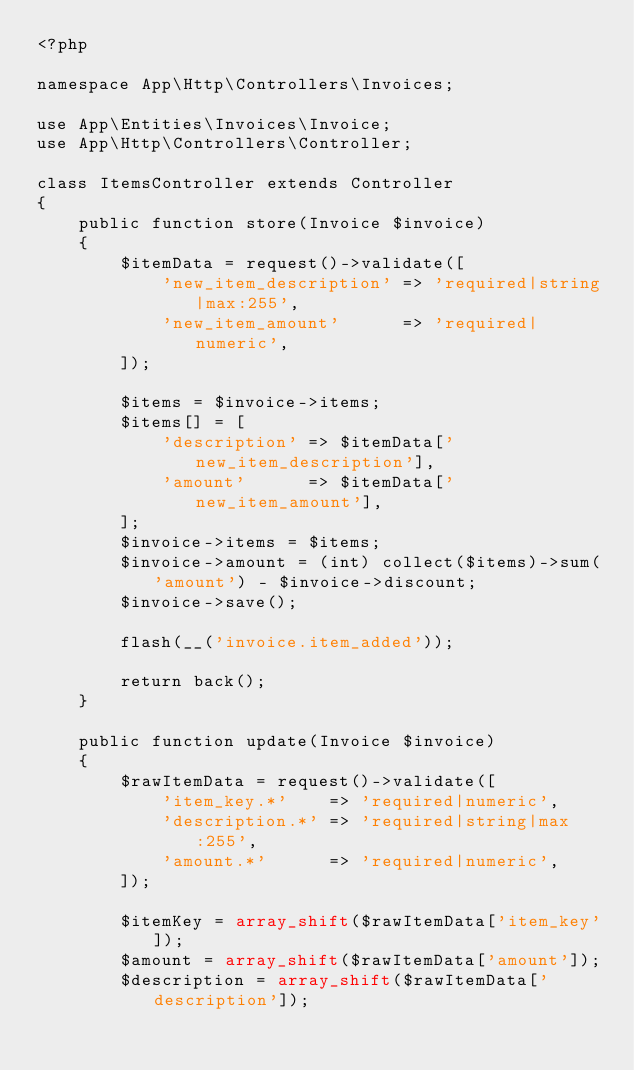<code> <loc_0><loc_0><loc_500><loc_500><_PHP_><?php

namespace App\Http\Controllers\Invoices;

use App\Entities\Invoices\Invoice;
use App\Http\Controllers\Controller;

class ItemsController extends Controller
{
    public function store(Invoice $invoice)
    {
        $itemData = request()->validate([
            'new_item_description' => 'required|string|max:255',
            'new_item_amount'      => 'required|numeric',
        ]);

        $items = $invoice->items;
        $items[] = [
            'description' => $itemData['new_item_description'],
            'amount'      => $itemData['new_item_amount'],
        ];
        $invoice->items = $items;
        $invoice->amount = (int) collect($items)->sum('amount') - $invoice->discount;
        $invoice->save();

        flash(__('invoice.item_added'));

        return back();
    }

    public function update(Invoice $invoice)
    {
        $rawItemData = request()->validate([
            'item_key.*'    => 'required|numeric',
            'description.*' => 'required|string|max:255',
            'amount.*'      => 'required|numeric',
        ]);

        $itemKey = array_shift($rawItemData['item_key']);
        $amount = array_shift($rawItemData['amount']);
        $description = array_shift($rawItemData['description']);
</code> 